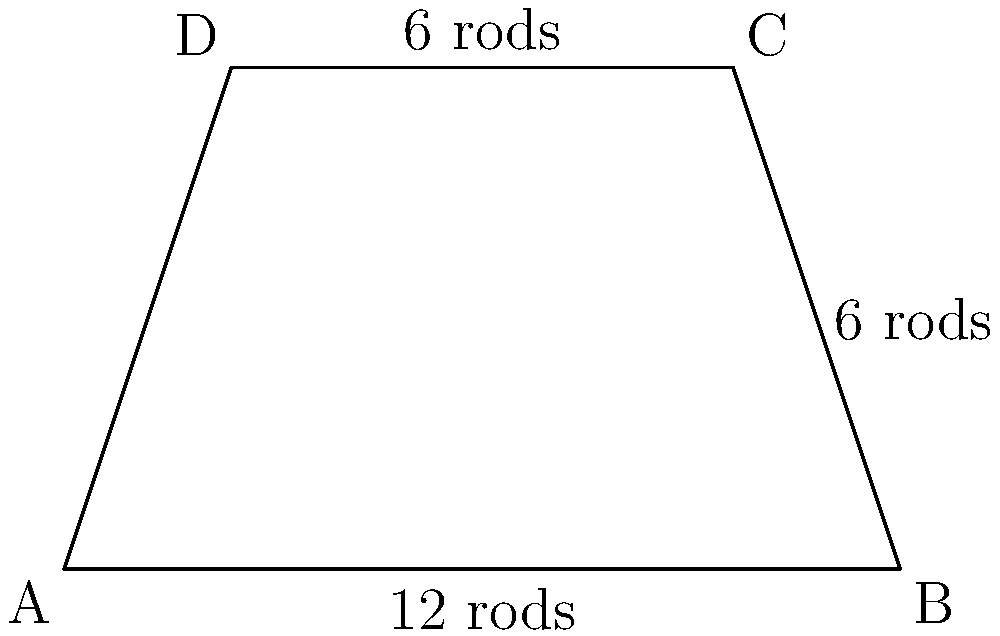In a colonial-era plantation, there's a trapezoidal plot of land used for growing tobacco. The parallel sides of the trapezoid measure 12 rods and 6 rods, while the height of the trapezoid is 6 rods. Considering that 1 square rod is equal to 272.25 square feet, what is the area of this plot in square feet? (Note: A rod is an old unit of measurement used in colonial times.) Let's approach this step-by-step:

1) First, we need to calculate the area of the trapezoidal plot in square rods.

2) The formula for the area of a trapezoid is:
   $$A = \frac{1}{2}(b_1 + b_2)h$$
   where $A$ is the area, $b_1$ and $b_2$ are the lengths of the parallel sides, and $h$ is the height.

3) Substituting our values:
   $$A = \frac{1}{2}(12 + 6) \times 6$$

4) Simplify:
   $$A = \frac{1}{2}(18) \times 6 = 9 \times 6 = 54$$

5) So, the area of the plot is 54 square rods.

6) Now, we need to convert this to square feet.
   We're given that 1 square rod = 272.25 square feet.

7) Therefore:
   $$54 \times 272.25 = 14,701.5$$

Thus, the area of the plot is 14,701.5 square feet.
Answer: 14,701.5 square feet 